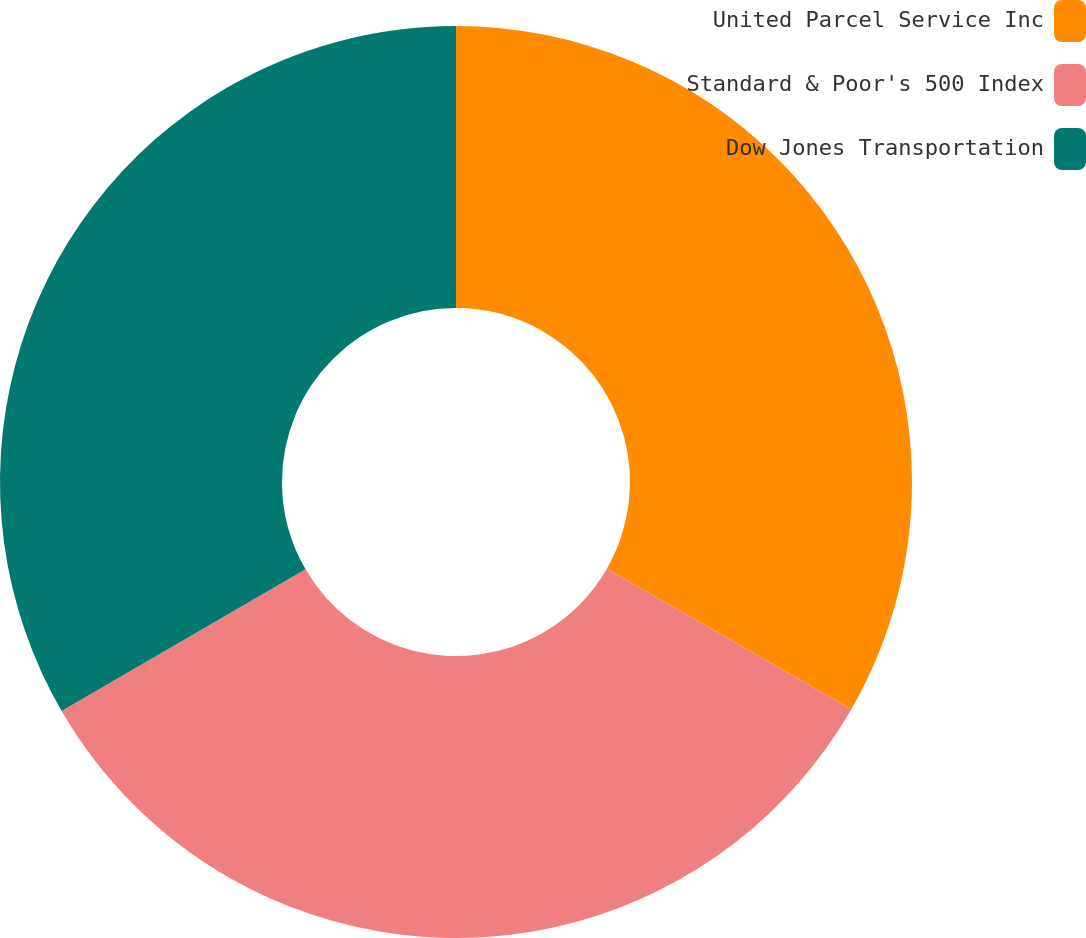Convert chart. <chart><loc_0><loc_0><loc_500><loc_500><pie_chart><fcel>United Parcel Service Inc<fcel>Standard & Poor's 500 Index<fcel>Dow Jones Transportation<nl><fcel>33.3%<fcel>33.33%<fcel>33.37%<nl></chart> 